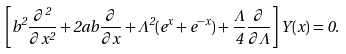<formula> <loc_0><loc_0><loc_500><loc_500>\left [ b ^ { 2 } \frac { \partial ^ { 2 } } { \partial x ^ { 2 } } + 2 a b \frac { \partial } { \partial x } + { \Lambda ^ { 2 } } ( e ^ { x } + e ^ { - x } ) + \frac { \Lambda } { 4 } \frac { \partial } { \partial \Lambda } \right ] Y ( x ) = 0 .</formula> 